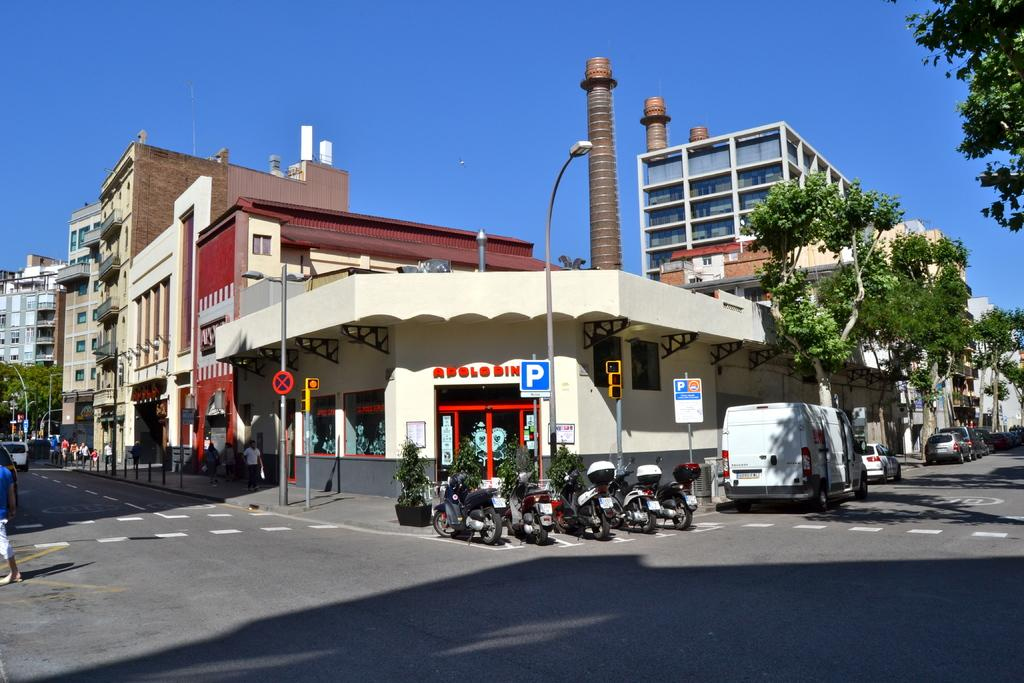What is located in the center of the image? There are vehicles in the center of the image. What can be seen in the background of the image? There are buildings and trees in the background of the image. Where are the persons located in the image? The persons are on the left side of the image. What safety feature is present on the road in the image? There is a zebra crossing on the road in the image. What type of glue is being used to fix the garden in the image? There is no mention of a garden or glue in the image; it features vehicles, buildings, trees, and persons. What is the aftermath of the accident in the image? There is no accident or aftermath depicted in the image; it shows a typical street scene with vehicles, buildings, trees, and persons. 